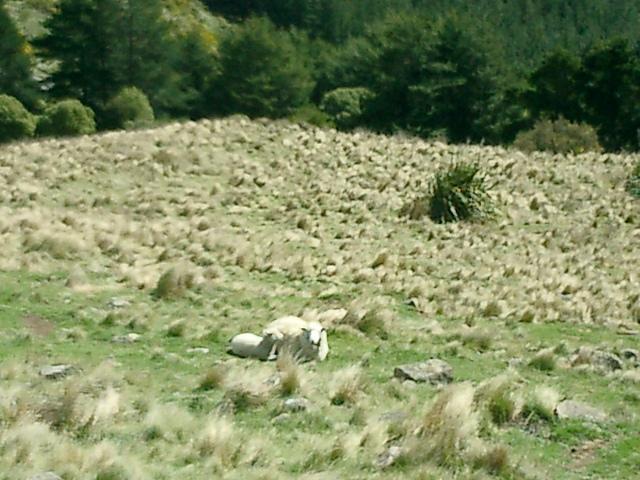How many farm animals?
Give a very brief answer. 2. How many animals are in the field?
Give a very brief answer. 2. How many people are wearing orange glasses?
Give a very brief answer. 0. 